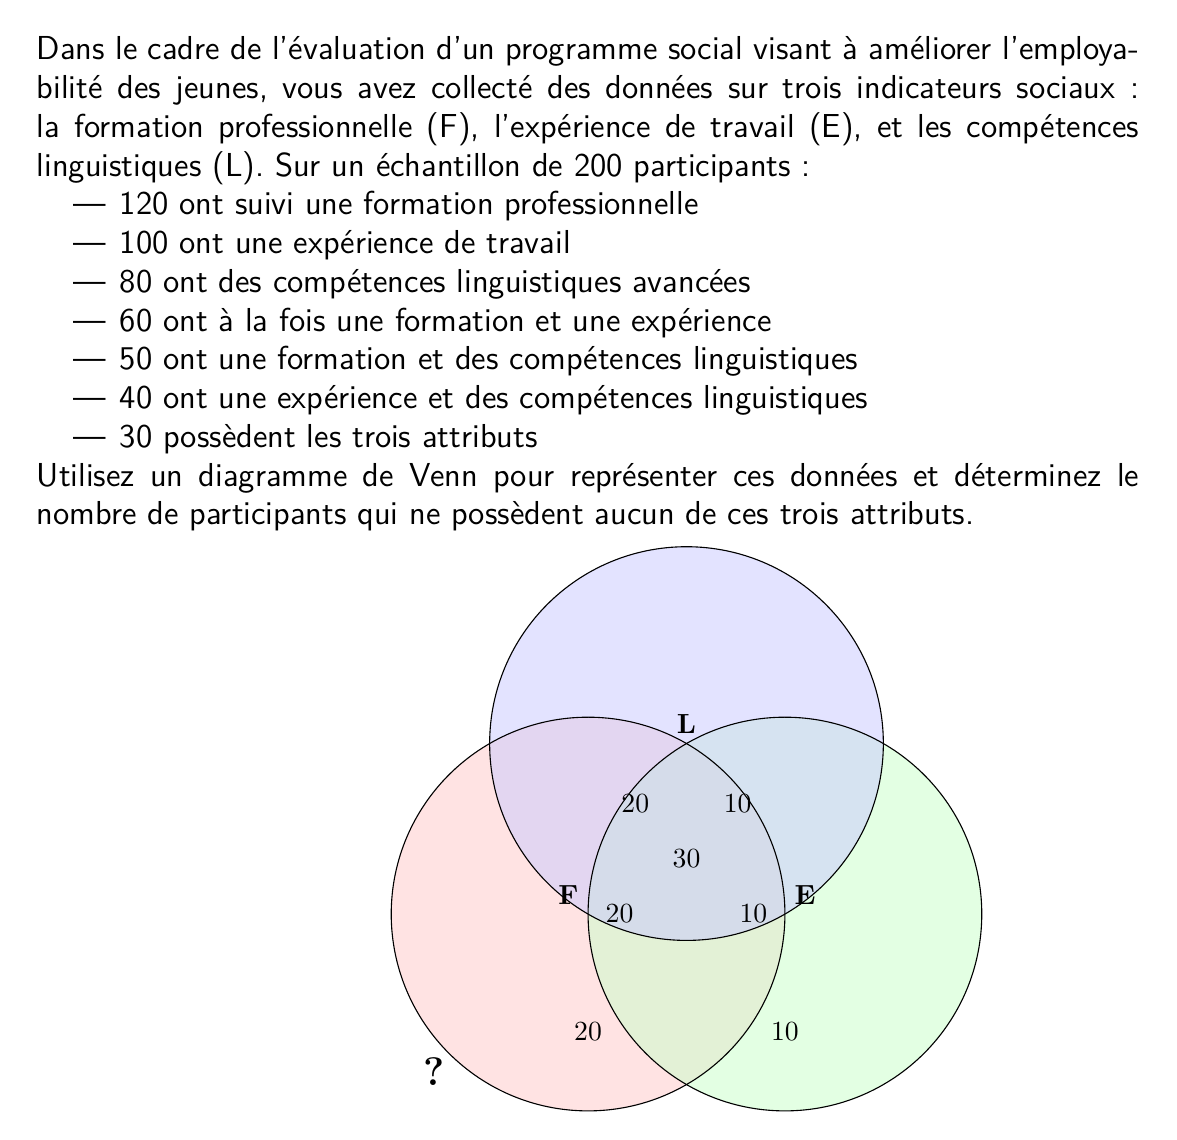Help me with this question. Pour résoudre ce problème, suivons ces étapes :

1) D'abord, identifions les informations données dans le diagramme de Venn :
   - F ∩ E ∩ L = 30 (centre)
   - F ∩ E (sans L) = 20
   - F ∩ L (sans E) = 20
   - E ∩ L (sans F) = 10
   - F uniquement = 20
   - E uniquement = 10
   - L uniquement = 10

2) Calculons le nombre total de participants dans chaque ensemble :
   F = 30 + 20 + 20 + 20 = 90
   E = 30 + 20 + 10 + 10 = 70
   L = 30 + 20 + 10 + 10 = 70

3) Vérifions ces totaux avec les données initiales :
   F devrait être 120, E devrait être 100, et L devrait être 80.
   Il y a une différence de 30 pour F, 30 pour E, et 10 pour L.

4) Ajustons les valeurs uniques pour chaque ensemble :
   F uniquement = 20 + 30 = 50
   E uniquement = 10 + 30 = 40
   L uniquement = 10 + 10 = 20

5) Calculons le nombre total de participants dans au moins un ensemble :
   $$ 50 + 40 + 20 + 20 + 20 + 10 + 30 = 190 $$

6) Le nombre total de participants est 200, donc le nombre de participants qui ne possèdent aucun attribut est :
   $$ 200 - 190 = 10 $$

Ainsi, 10 participants ne possèdent aucun des trois attributs.
Answer: 10 